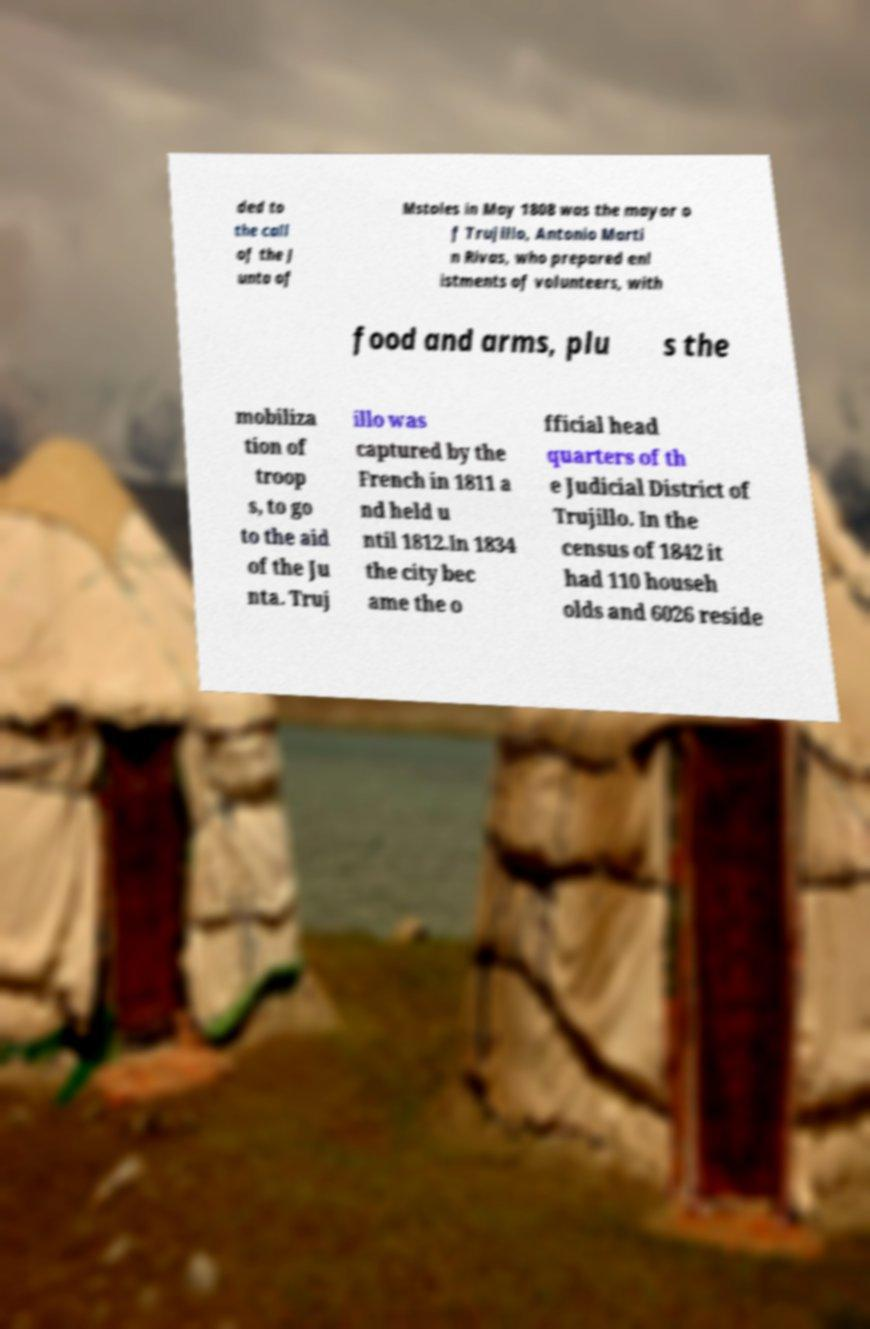Please identify and transcribe the text found in this image. ded to the call of the J unta of Mstoles in May 1808 was the mayor o f Trujillo, Antonio Marti n Rivas, who prepared enl istments of volunteers, with food and arms, plu s the mobiliza tion of troop s, to go to the aid of the Ju nta. Truj illo was captured by the French in 1811 a nd held u ntil 1812.In 1834 the city bec ame the o fficial head quarters of th e Judicial District of Trujillo. In the census of 1842 it had 110 househ olds and 6026 reside 